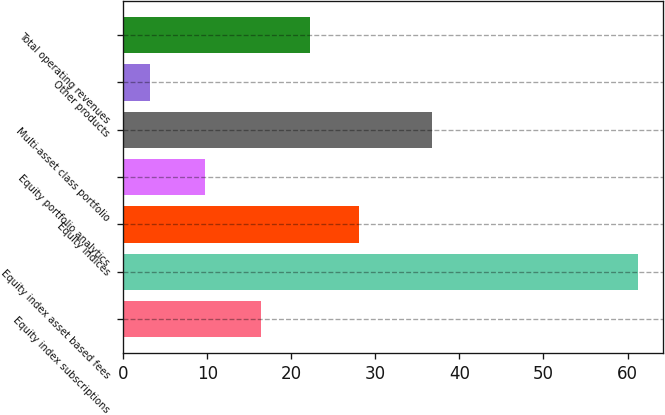Convert chart. <chart><loc_0><loc_0><loc_500><loc_500><bar_chart><fcel>Equity index subscriptions<fcel>Equity index asset based fees<fcel>Equity indices<fcel>Equity portfolio analytics<fcel>Multi-asset class portfolio<fcel>Other products<fcel>Total operating revenues<nl><fcel>16.4<fcel>61.2<fcel>28<fcel>9.7<fcel>36.7<fcel>3.2<fcel>22.2<nl></chart> 